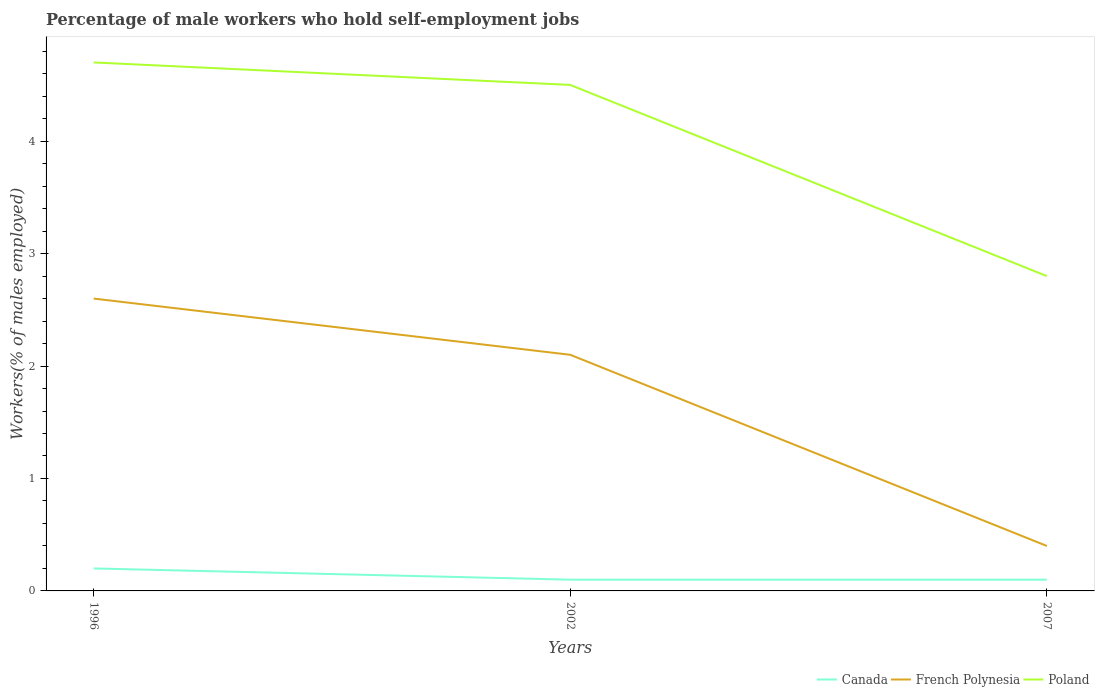Does the line corresponding to Canada intersect with the line corresponding to French Polynesia?
Your answer should be compact. No. Is the number of lines equal to the number of legend labels?
Offer a very short reply. Yes. Across all years, what is the maximum percentage of self-employed male workers in Poland?
Your response must be concise. 2.8. In which year was the percentage of self-employed male workers in French Polynesia maximum?
Your answer should be compact. 2007. What is the total percentage of self-employed male workers in French Polynesia in the graph?
Your response must be concise. 0.5. What is the difference between the highest and the second highest percentage of self-employed male workers in French Polynesia?
Make the answer very short. 2.2. How many years are there in the graph?
Provide a short and direct response. 3. Are the values on the major ticks of Y-axis written in scientific E-notation?
Provide a short and direct response. No. Does the graph contain any zero values?
Keep it short and to the point. No. Where does the legend appear in the graph?
Provide a succinct answer. Bottom right. How many legend labels are there?
Make the answer very short. 3. How are the legend labels stacked?
Your answer should be very brief. Horizontal. What is the title of the graph?
Provide a short and direct response. Percentage of male workers who hold self-employment jobs. Does "Egypt, Arab Rep." appear as one of the legend labels in the graph?
Keep it short and to the point. No. What is the label or title of the Y-axis?
Offer a terse response. Workers(% of males employed). What is the Workers(% of males employed) of Canada in 1996?
Give a very brief answer. 0.2. What is the Workers(% of males employed) of French Polynesia in 1996?
Keep it short and to the point. 2.6. What is the Workers(% of males employed) of Poland in 1996?
Give a very brief answer. 4.7. What is the Workers(% of males employed) in Canada in 2002?
Offer a terse response. 0.1. What is the Workers(% of males employed) of French Polynesia in 2002?
Offer a very short reply. 2.1. What is the Workers(% of males employed) in Canada in 2007?
Your answer should be compact. 0.1. What is the Workers(% of males employed) of French Polynesia in 2007?
Your answer should be very brief. 0.4. What is the Workers(% of males employed) in Poland in 2007?
Provide a succinct answer. 2.8. Across all years, what is the maximum Workers(% of males employed) of Canada?
Keep it short and to the point. 0.2. Across all years, what is the maximum Workers(% of males employed) in French Polynesia?
Your answer should be compact. 2.6. Across all years, what is the maximum Workers(% of males employed) of Poland?
Give a very brief answer. 4.7. Across all years, what is the minimum Workers(% of males employed) in Canada?
Your answer should be compact. 0.1. Across all years, what is the minimum Workers(% of males employed) of French Polynesia?
Offer a very short reply. 0.4. Across all years, what is the minimum Workers(% of males employed) of Poland?
Your answer should be compact. 2.8. What is the total Workers(% of males employed) of Canada in the graph?
Make the answer very short. 0.4. What is the total Workers(% of males employed) in French Polynesia in the graph?
Your answer should be compact. 5.1. What is the difference between the Workers(% of males employed) of Canada in 1996 and that in 2002?
Provide a succinct answer. 0.1. What is the difference between the Workers(% of males employed) in Poland in 1996 and that in 2002?
Ensure brevity in your answer.  0.2. What is the difference between the Workers(% of males employed) in French Polynesia in 1996 and that in 2007?
Your answer should be very brief. 2.2. What is the difference between the Workers(% of males employed) in French Polynesia in 2002 and that in 2007?
Provide a succinct answer. 1.7. What is the difference between the Workers(% of males employed) in Canada in 1996 and the Workers(% of males employed) in French Polynesia in 2002?
Offer a terse response. -1.9. What is the difference between the Workers(% of males employed) of Canada in 1996 and the Workers(% of males employed) of Poland in 2002?
Your response must be concise. -4.3. What is the difference between the Workers(% of males employed) in French Polynesia in 1996 and the Workers(% of males employed) in Poland in 2002?
Give a very brief answer. -1.9. What is the difference between the Workers(% of males employed) in Canada in 1996 and the Workers(% of males employed) in French Polynesia in 2007?
Keep it short and to the point. -0.2. What is the difference between the Workers(% of males employed) in French Polynesia in 1996 and the Workers(% of males employed) in Poland in 2007?
Your answer should be very brief. -0.2. What is the difference between the Workers(% of males employed) in Canada in 2002 and the Workers(% of males employed) in French Polynesia in 2007?
Your answer should be very brief. -0.3. What is the difference between the Workers(% of males employed) of French Polynesia in 2002 and the Workers(% of males employed) of Poland in 2007?
Give a very brief answer. -0.7. What is the average Workers(% of males employed) in Canada per year?
Provide a short and direct response. 0.13. What is the average Workers(% of males employed) in French Polynesia per year?
Keep it short and to the point. 1.7. What is the average Workers(% of males employed) of Poland per year?
Keep it short and to the point. 4. In the year 1996, what is the difference between the Workers(% of males employed) in Canada and Workers(% of males employed) in Poland?
Your answer should be compact. -4.5. In the year 2002, what is the difference between the Workers(% of males employed) of Canada and Workers(% of males employed) of Poland?
Ensure brevity in your answer.  -4.4. What is the ratio of the Workers(% of males employed) in Canada in 1996 to that in 2002?
Your answer should be very brief. 2. What is the ratio of the Workers(% of males employed) of French Polynesia in 1996 to that in 2002?
Make the answer very short. 1.24. What is the ratio of the Workers(% of males employed) in Poland in 1996 to that in 2002?
Make the answer very short. 1.04. What is the ratio of the Workers(% of males employed) of Canada in 1996 to that in 2007?
Provide a succinct answer. 2. What is the ratio of the Workers(% of males employed) of Poland in 1996 to that in 2007?
Your answer should be compact. 1.68. What is the ratio of the Workers(% of males employed) of Canada in 2002 to that in 2007?
Offer a very short reply. 1. What is the ratio of the Workers(% of males employed) of French Polynesia in 2002 to that in 2007?
Give a very brief answer. 5.25. What is the ratio of the Workers(% of males employed) of Poland in 2002 to that in 2007?
Your response must be concise. 1.61. What is the difference between the highest and the lowest Workers(% of males employed) in Canada?
Your answer should be compact. 0.1. What is the difference between the highest and the lowest Workers(% of males employed) in French Polynesia?
Offer a terse response. 2.2. 